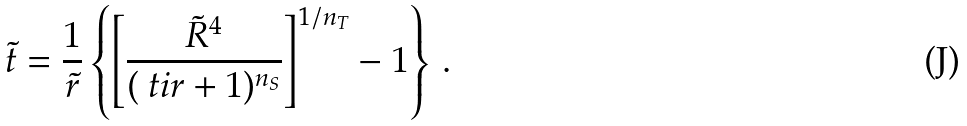Convert formula to latex. <formula><loc_0><loc_0><loc_500><loc_500>\tilde { t } = \frac { 1 } { \tilde { r } } \left \{ \left [ \frac { \tilde { R } ^ { 4 } } { ( \ t i r + 1 ) ^ { n _ { S } } } \right ] ^ { 1 / n _ { T } } - 1 \right \} \, .</formula> 